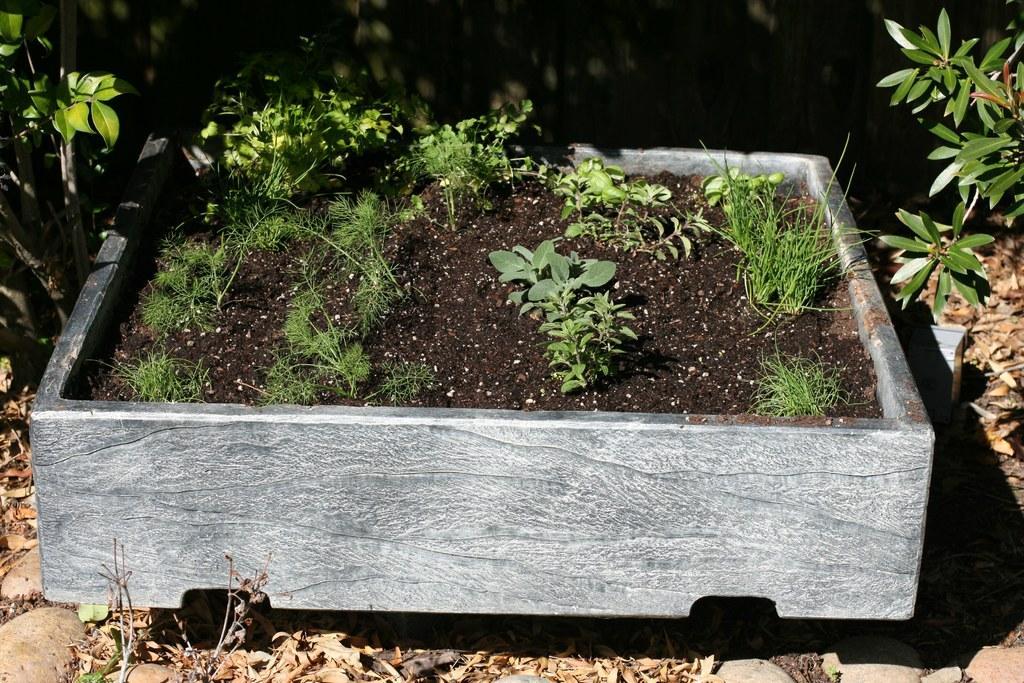Could you give a brief overview of what you see in this image? In this image there are tiny plants in a pot, and in the background there are plants. 